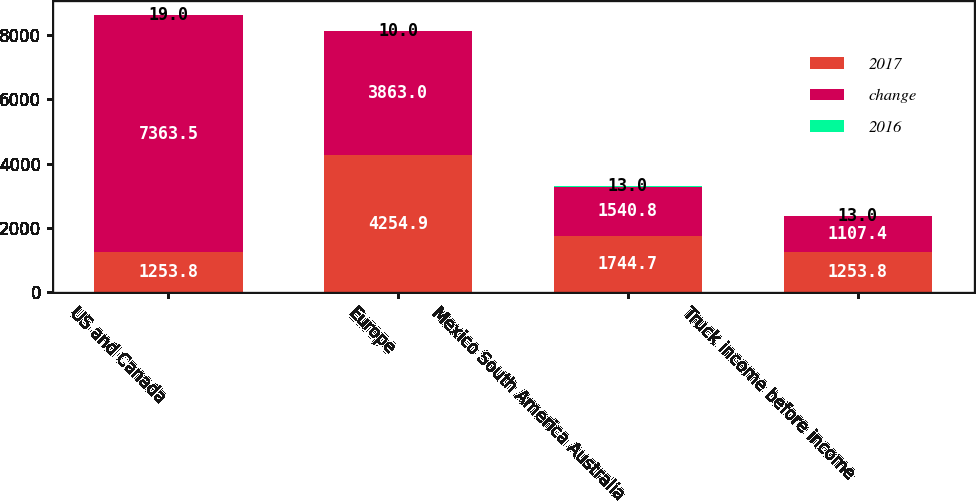<chart> <loc_0><loc_0><loc_500><loc_500><stacked_bar_chart><ecel><fcel>US and Canada<fcel>Europe<fcel>Mexico South America Australia<fcel>Truck income before income<nl><fcel>2017<fcel>1253.8<fcel>4254.9<fcel>1744.7<fcel>1253.8<nl><fcel>change<fcel>7363.5<fcel>3863<fcel>1540.8<fcel>1107.4<nl><fcel>2016<fcel>19<fcel>10<fcel>13<fcel>13<nl></chart> 